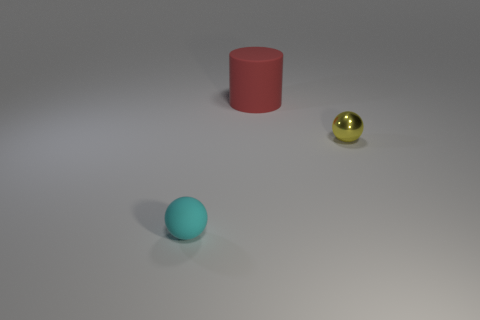What is the material of the tiny cyan object that is the same shape as the tiny yellow object?
Make the answer very short. Rubber. Are there any yellow metal spheres that are behind the tiny thing behind the tiny thing that is on the left side of the small yellow metallic ball?
Give a very brief answer. No. Does the cyan object have the same shape as the matte thing that is behind the tiny cyan matte thing?
Offer a very short reply. No. Is there anything else that has the same color as the large thing?
Your answer should be compact. No. There is a rubber thing that is in front of the red rubber object; is its color the same as the tiny ball that is to the right of the big red cylinder?
Provide a succinct answer. No. Is there a large rubber thing?
Your response must be concise. Yes. Is there a purple ball that has the same material as the yellow object?
Offer a very short reply. No. Are there any other things that have the same material as the yellow sphere?
Offer a very short reply. No. What color is the tiny metallic object?
Offer a terse response. Yellow. What is the color of the thing that is the same size as the yellow metallic ball?
Your answer should be very brief. Cyan. 